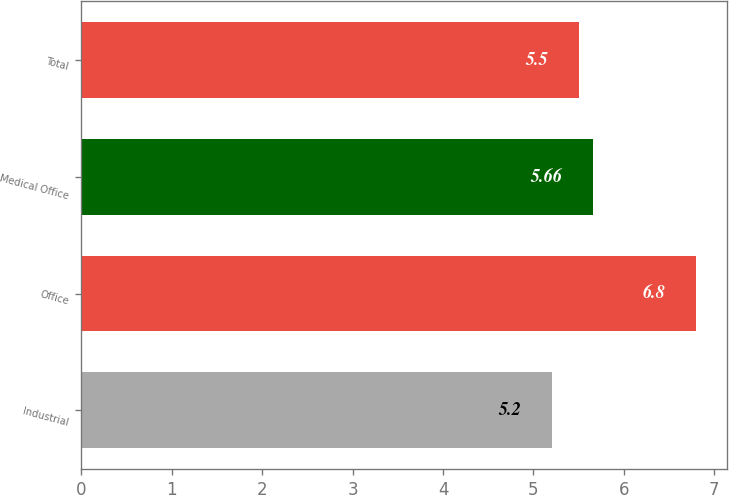Convert chart to OTSL. <chart><loc_0><loc_0><loc_500><loc_500><bar_chart><fcel>Industrial<fcel>Office<fcel>Medical Office<fcel>Total<nl><fcel>5.2<fcel>6.8<fcel>5.66<fcel>5.5<nl></chart> 